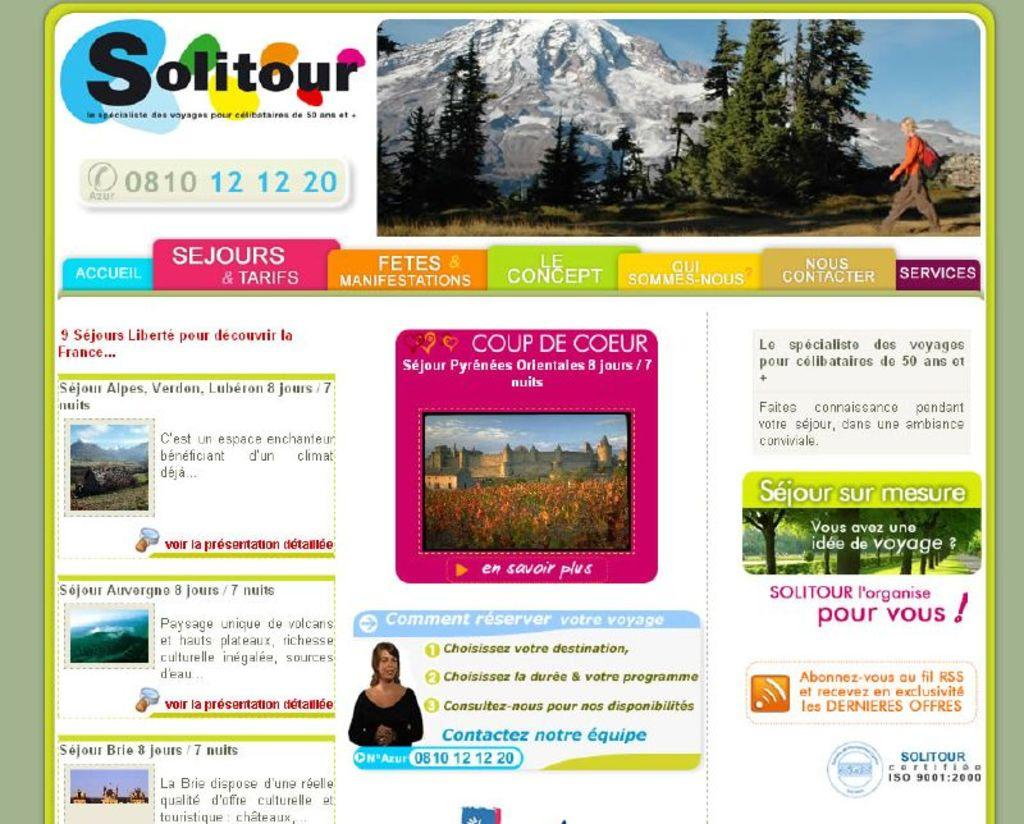What type of image is being described? The image is a digital poster. What geographical features can be seen in the image? There are mountains and trees in the image. How many eyes can be seen on the mountains in the image? There are no eyes present on the mountains in the image; it features mountains and trees. What type of vegetable is growing on the trees in the image? There is no vegetable growing on the trees in the image; it only features trees and mountains. 